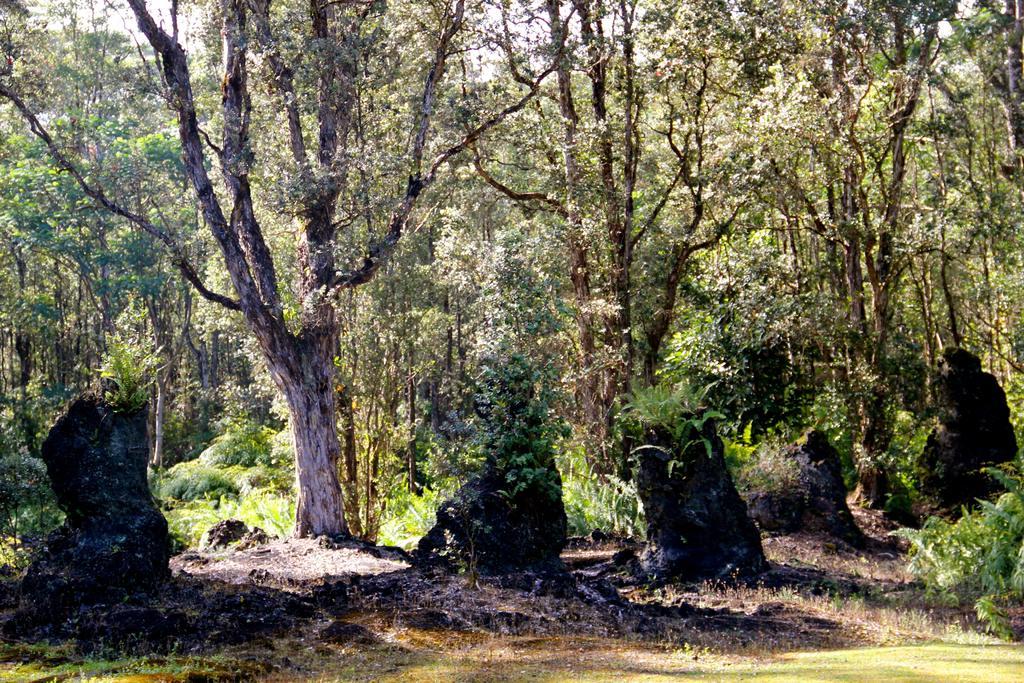Can you describe this image briefly? In this image in the foreground there are some trees, and at the bottom there is grass and sand. 